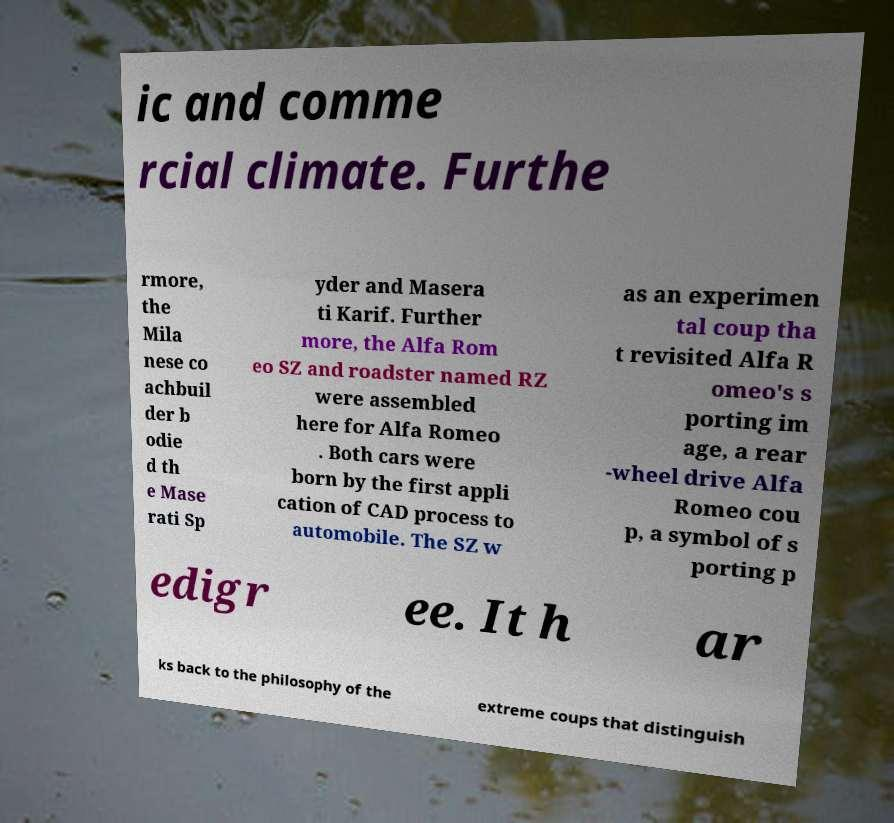Could you extract and type out the text from this image? ic and comme rcial climate. Furthe rmore, the Mila nese co achbuil der b odie d th e Mase rati Sp yder and Masera ti Karif. Further more, the Alfa Rom eo SZ and roadster named RZ were assembled here for Alfa Romeo . Both cars were born by the first appli cation of CAD process to automobile. The SZ w as an experimen tal coup tha t revisited Alfa R omeo's s porting im age, a rear -wheel drive Alfa Romeo cou p, a symbol of s porting p edigr ee. It h ar ks back to the philosophy of the extreme coups that distinguish 